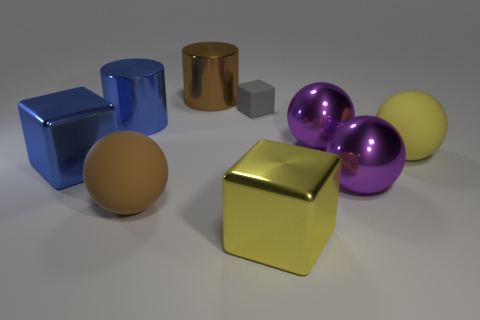How many things are tiny cubes or matte objects that are on the left side of the large yellow metal object?
Ensure brevity in your answer.  2. There is a metal cylinder that is on the left side of the brown cylinder; does it have the same size as the tiny gray matte block?
Offer a terse response. No. What is the material of the large brown thing in front of the small gray object?
Ensure brevity in your answer.  Rubber. Are there an equal number of yellow matte balls in front of the yellow metallic block and blocks behind the big blue cylinder?
Keep it short and to the point. No. The other rubber thing that is the same shape as the yellow rubber object is what color?
Offer a terse response. Brown. What number of metallic objects are either purple things or yellow cubes?
Keep it short and to the point. 3. Is the number of brown matte spheres that are left of the large brown metal thing greater than the number of tiny red matte blocks?
Offer a terse response. Yes. How many other things are there of the same material as the big blue cylinder?
Your answer should be very brief. 5. How many large objects are either yellow balls or yellow shiny things?
Provide a short and direct response. 2. Are the brown sphere and the big blue block made of the same material?
Provide a succinct answer. No. 